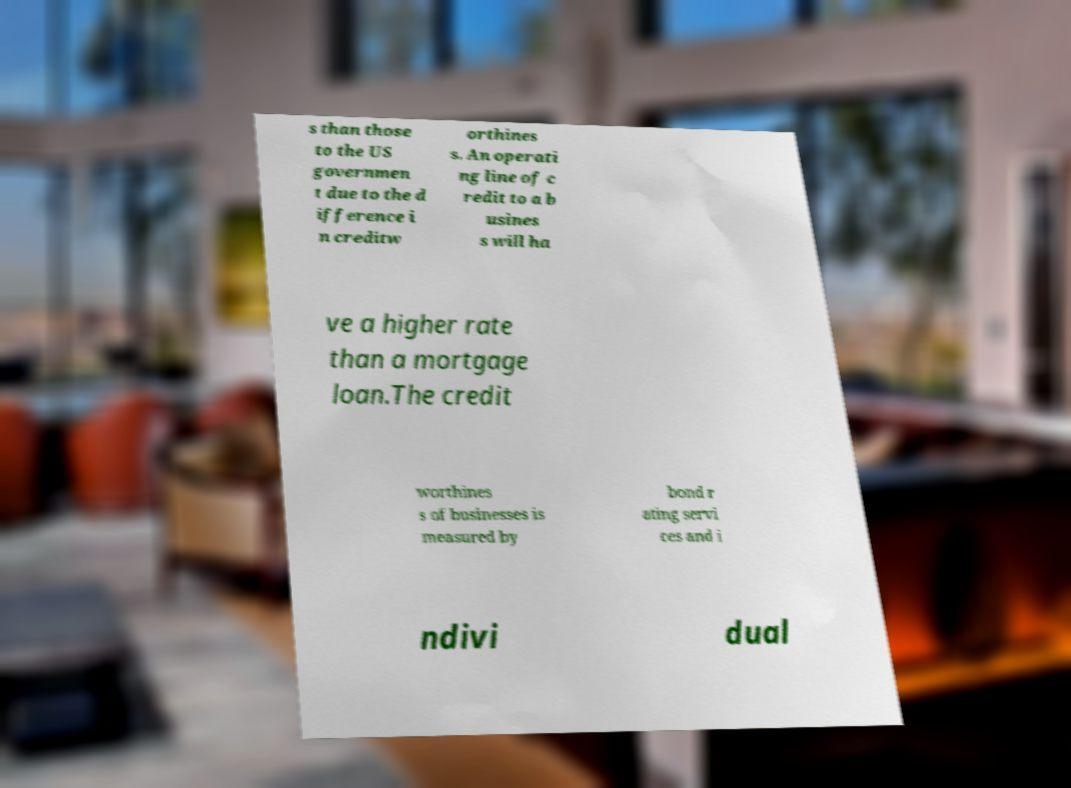I need the written content from this picture converted into text. Can you do that? s than those to the US governmen t due to the d ifference i n creditw orthines s. An operati ng line of c redit to a b usines s will ha ve a higher rate than a mortgage loan.The credit worthines s of businesses is measured by bond r ating servi ces and i ndivi dual 